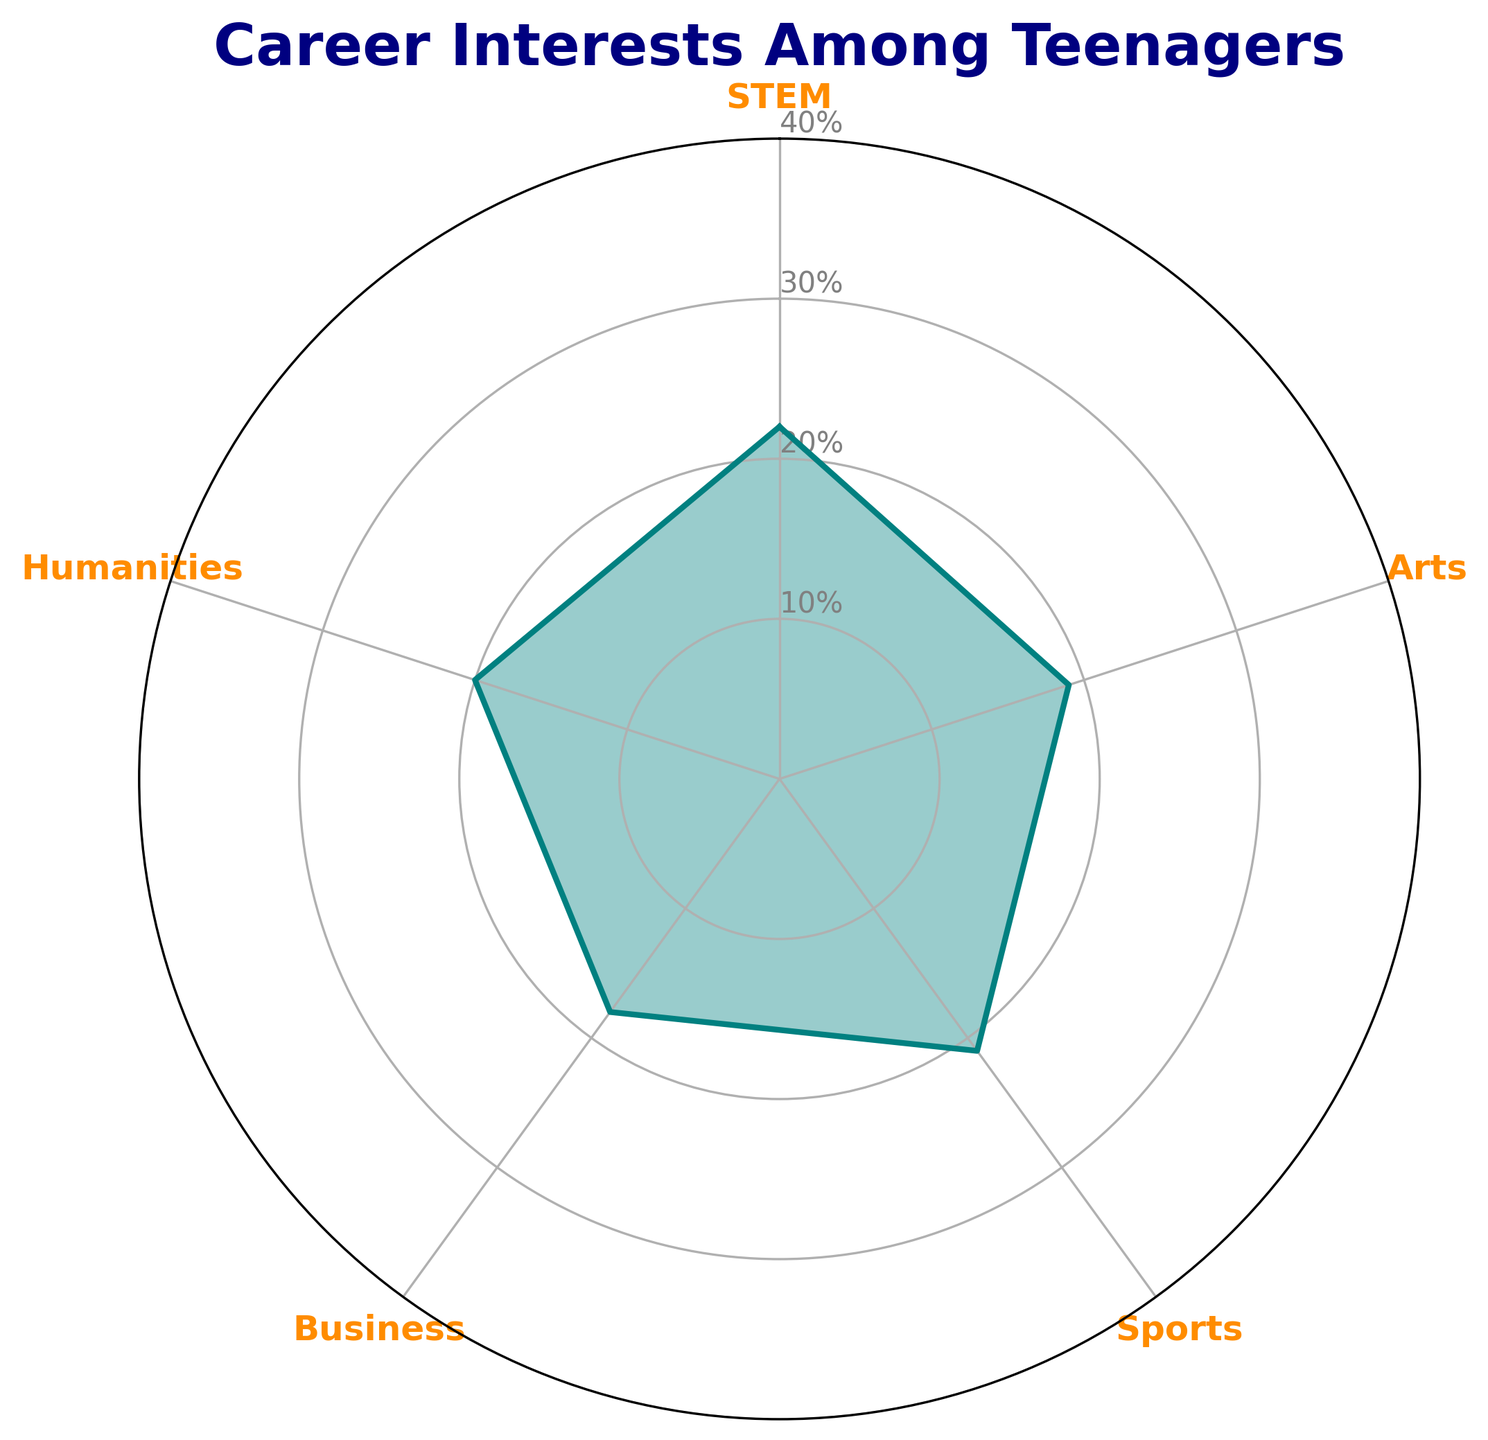what's the category with the highest percentage? Locate the highest point on the radar chart where the plot line touches the outer edge. The category labeled at this point is the one with the highest percentage. This label is located on the outermost circle of the related angle representing "STEM".
Answer: STEM what's the difference between the highest and lowest percentages? Identify the highest (STEM: 22%) and lowest (Business: 18%) percentages by locating the outermost and innermost points on the radar chart. Subtract the smallest percentage from the largest. 22% - 18% = 4%
Answer: 4% which categories have a higher percentage than Sports? Compare all other category percentages against Sports (21%). The radar chart shows STEM (22%) and Humanities (20%) and only "STEM" has a higher percentage.
Answer: STEM what are the sum of percentages for Arts and Business? Find the percentages of Arts (19%) and Business (18%) on the radar chart and add them. 19% + 18% = 37%
Answer: 37% which category is closest in percentage to Humanities? Identify the percentage of Humanities (20%) and compare it with other categories' percentages. Both Arts (19%) and Sports (21%) are close, but Arts is closer by a 1% difference.
Answer: Arts what do all the inner concentric circles represent? The inner concentric circles on the radar chart represent different levels of percentages. The radial lines intersect these circles indicating various percentage values. In this chart, the circles are labeled 10%, 20%, 30%, and 40%.
Answer: Various percentage levels how many categories have a percentage below 20%? Identify categories with percentages less than 20% by looking at points inside the 20% inner circle. Arts (19%) and Business (18%) fall below this threshold.
Answer: 2 what's the average percentage across all categories? Sum the percentages of all categories (22% + 19% + 21% + 18% + 20%) and divide by the number of categories (5). Total sum: 100%, Average: 100% / 5 = 20%
Answer: 20% how is the color used to highlight the plot? The radar chart uses teal color to plot the line and fill the area between the line and the origin, with an alpha (transparency) of 0.4 to make it semi-transparent, enhancing visual clarity.
Answer: Teal with semi-transparency 